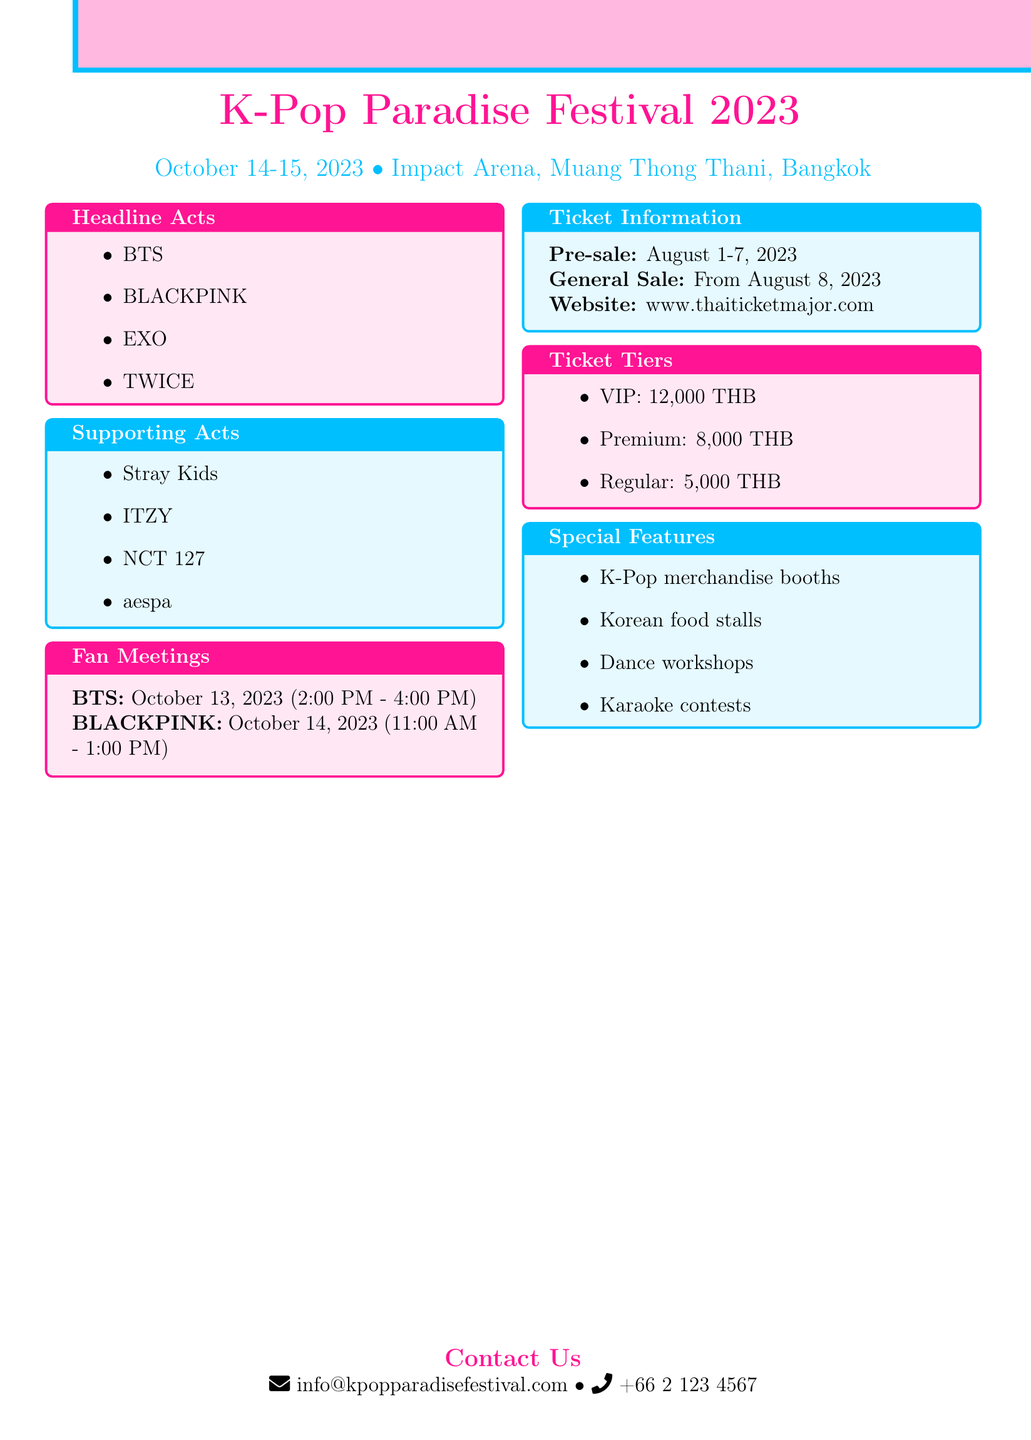What are the dates of the festival? The festival is scheduled to take place on October 14-15, 2023.
Answer: October 14-15, 2023 Where is the K-Pop Paradise Festival being held? The venue for the festival is Impact Arena, Muang Thong Thani, Bangkok.
Answer: Impact Arena, Muang Thong Thani, Bangkok Which groups are performing as headline acts? The headline acts mentioned in the document include BTS, BLACKPINK, EXO, and TWICE.
Answer: BTS, BLACKPINK, EXO, TWICE When does the ticket presale start? The presale for tickets starts on August 1, 2023.
Answer: August 1, 2023 What is the price of VIP tickets? The price listed for VIP tickets is 12,000 THB.
Answer: 12,000 THB Which group has a fan meeting on October 14, 2023? The document states that BLACKPINK has a fan meeting on that date.
Answer: BLACKPINK How long is the BTS fan meeting scheduled for? The fan meeting for BTS is scheduled from 2:00 PM to 4:00 PM, making it a 2-hour event.
Answer: 2 hours What types of special features will be at the festival? The special features include K-Pop merchandise booths, Korean food stalls, dance workshops, and karaoke contests.
Answer: K-Pop merchandise booths, Korean food stalls, dance workshops, karaoke contests Who can be contacted for more information regarding the festival? For inquiries, the contact information provided includes the email info@kpopparadisefestival.com and phone number +66 2 123 4567.
Answer: info@kpopparadisefestival.com, +66 2 123 4567 